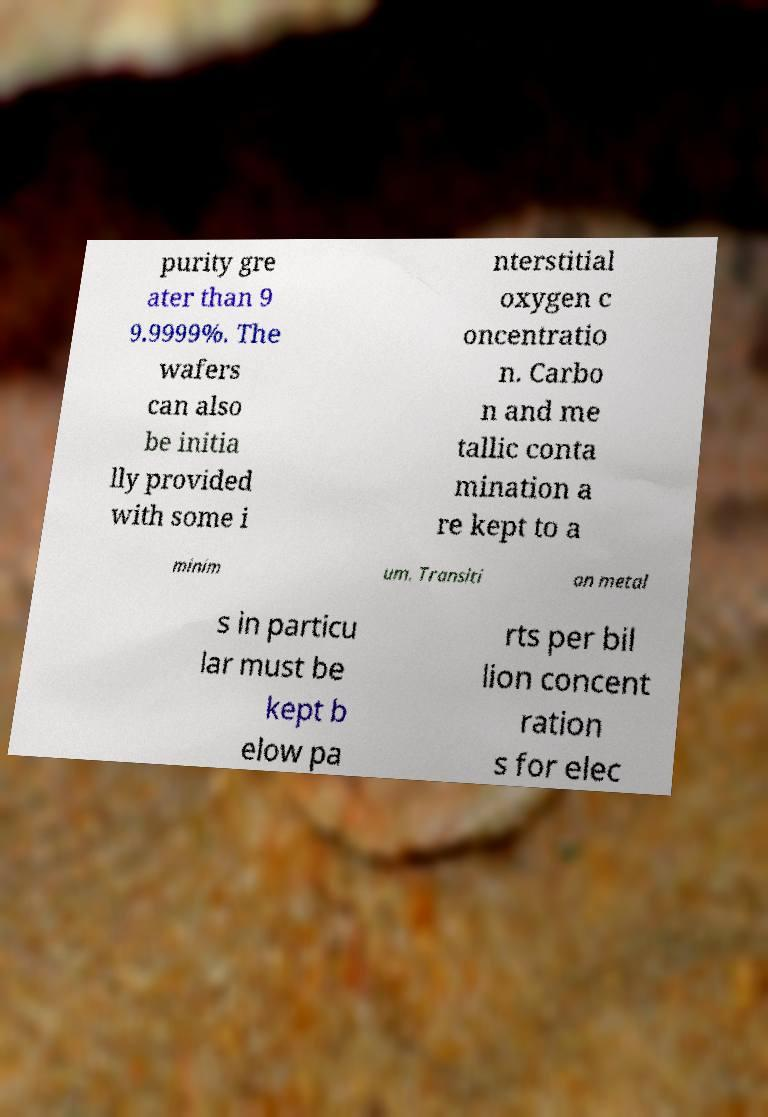There's text embedded in this image that I need extracted. Can you transcribe it verbatim? purity gre ater than 9 9.9999%. The wafers can also be initia lly provided with some i nterstitial oxygen c oncentratio n. Carbo n and me tallic conta mination a re kept to a minim um. Transiti on metal s in particu lar must be kept b elow pa rts per bil lion concent ration s for elec 